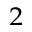Convert formula to latex. <formula><loc_0><loc_0><loc_500><loc_500>^ { 2 }</formula> 